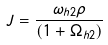Convert formula to latex. <formula><loc_0><loc_0><loc_500><loc_500>J = \frac { \omega _ { h 2 } \rho } { ( 1 + \Omega _ { h 2 } ) }</formula> 